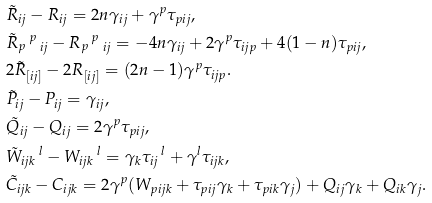Convert formula to latex. <formula><loc_0><loc_0><loc_500><loc_500>& \tilde { R } _ { i j } - R _ { i j } = 2 n \gamma _ { i j } + \gamma ^ { p } \tau _ { p i j } , \\ & \tilde { R } _ { p } \, ^ { p } \, _ { i j } - R _ { p } \, ^ { p } \, _ { i j } = - 4 n \gamma _ { i j } + 2 \gamma ^ { p } \tau _ { i j p } + 4 ( 1 - n ) \tau _ { p i j } , \\ & 2 \tilde { R } _ { [ i j ] } - 2 R _ { [ i j ] } = ( 2 n - 1 ) \gamma ^ { p } \tau _ { i j p } . & \\ & \tilde { P } _ { i j } - P _ { i j } = \gamma _ { i j } , \\ & \tilde { Q } _ { i j } - Q _ { i j } = 2 \gamma ^ { p } \tau _ { p i j } , \\ & \tilde { W } _ { i j k } \, ^ { l } - W _ { i j k } \, ^ { l } = \gamma _ { k } \tau _ { i j } \, ^ { l } + \gamma ^ { l } \tau _ { i j k } , \\ & \tilde { C } _ { i j k } - C _ { i j k } = 2 \gamma ^ { p } ( W _ { p i j k } + \tau _ { p i j } \gamma _ { k } + \tau _ { p i k } \gamma _ { j } ) + Q _ { i j } \gamma _ { k } + Q _ { i k } \gamma _ { j } .</formula> 